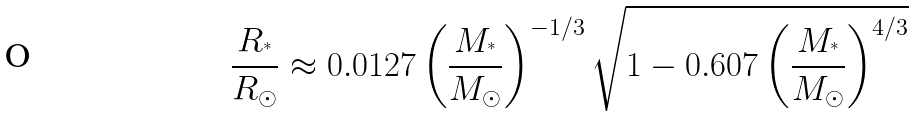<formula> <loc_0><loc_0><loc_500><loc_500>\frac { R _ { ^ { * } } } { R _ { \odot } } \approx 0 . 0 1 2 7 \left ( \frac { M _ { ^ { * } } } { M _ { \odot } } \right ) ^ { - 1 / 3 } \sqrt { 1 - 0 . 6 0 7 \left ( \frac { M _ { ^ { * } } } { M _ { \odot } } \right ) ^ { 4 / 3 } }</formula> 